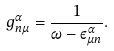Convert formula to latex. <formula><loc_0><loc_0><loc_500><loc_500>g _ { n \mu } ^ { \alpha } = \frac { 1 } { \omega - \varepsilon _ { \mu n } ^ { \alpha } } .</formula> 